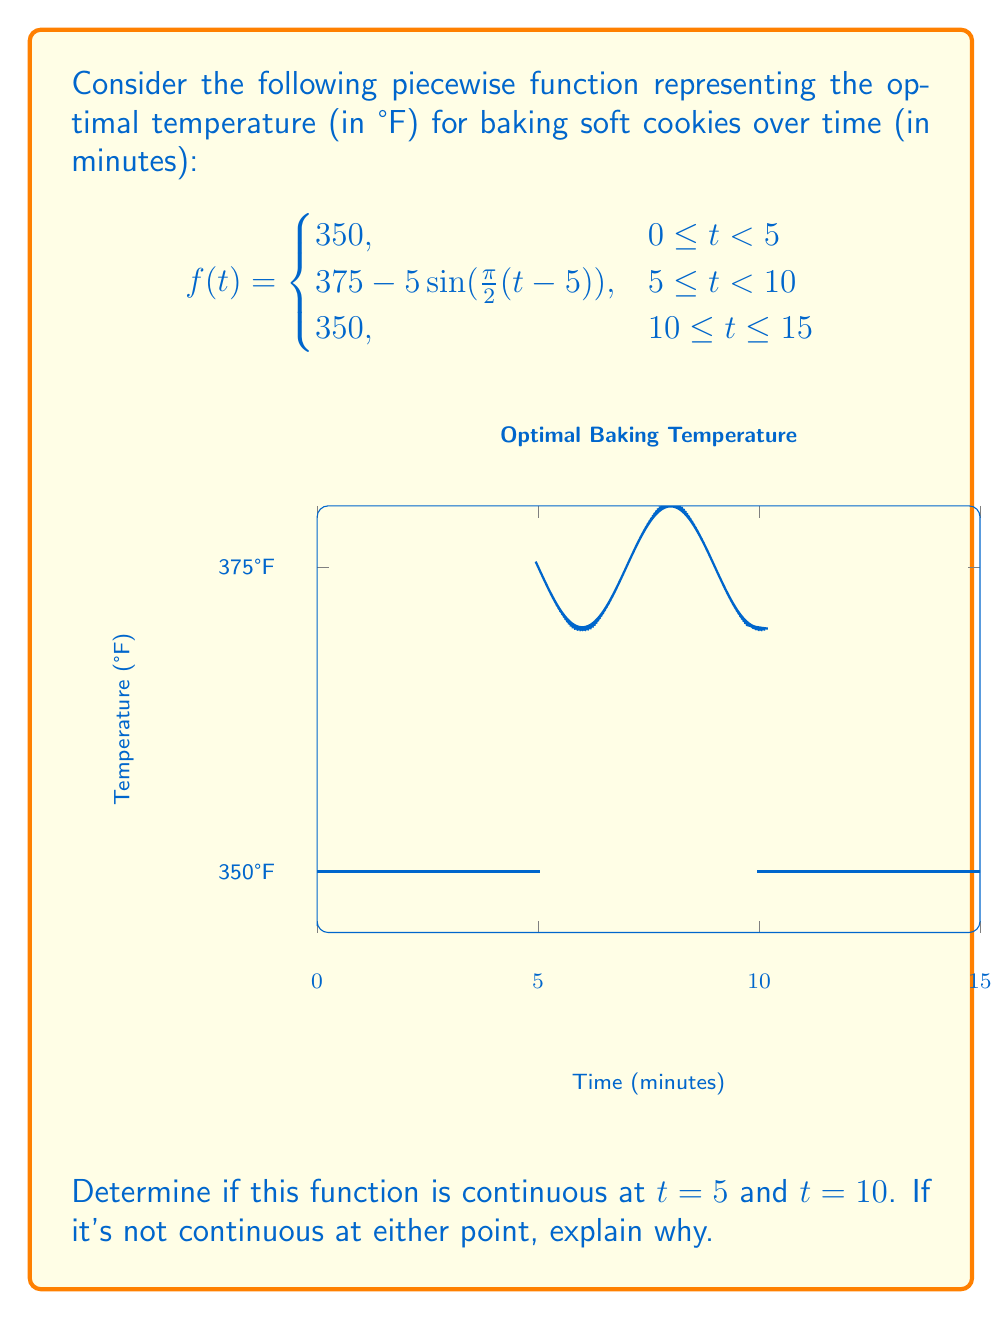Can you solve this math problem? To determine if the function is continuous at $t = 5$ and $t = 10$, we need to check three conditions for each point:

1. The function is defined at the point.
2. The limit of the function as we approach the point from both sides exists.
3. The limit equals the function value at that point.

For $t = 5$:

1. $f(5)$ is defined: $f(5) = 375 - 5\sin(\frac{\pi}{2}(5-5)) = 375 - 5\sin(0) = 375$
2. Left limit: $\lim_{t \to 5^-} f(t) = 350$
   Right limit: $\lim_{t \to 5^+} f(t) = 375 - 5\sin(0) = 375$
3. $f(5) = 375$, which equals the right limit but not the left limit.

Since the left limit doesn't equal the right limit, the function is not continuous at $t = 5$.

For $t = 10$:

1. $f(10)$ is defined: $f(10) = 350$
2. Left limit: $\lim_{t \to 10^-} f(t) = 375 - 5\sin(\frac{\pi}{2}(10-5)) = 375 - 5\sin(\frac{5\pi}{2}) = 375 - 5 = 370$
   Right limit: $\lim_{t \to 10^+} f(t) = 350$
3. $f(10) = 350$, which equals the right limit but not the left limit.

Since the left limit doesn't equal the right limit, the function is not continuous at $t = 10$.

Therefore, the function is not continuous at either $t = 5$ or $t = 10$. The discontinuities are due to the sudden changes in temperature at these points, which would be impractical for baking soft cookies in real life.
Answer: Not continuous at $t = 5$ and $t = 10$ due to unequal left and right limits. 